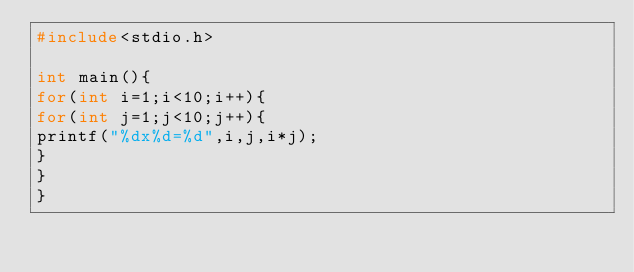Convert code to text. <code><loc_0><loc_0><loc_500><loc_500><_C_>#include<stdio.h>

int main(){
for(int i=1;i<10;i++){
for(int j=1;j<10;j++){
printf("%dx%d=%d",i,j,i*j);
}
}
}</code> 